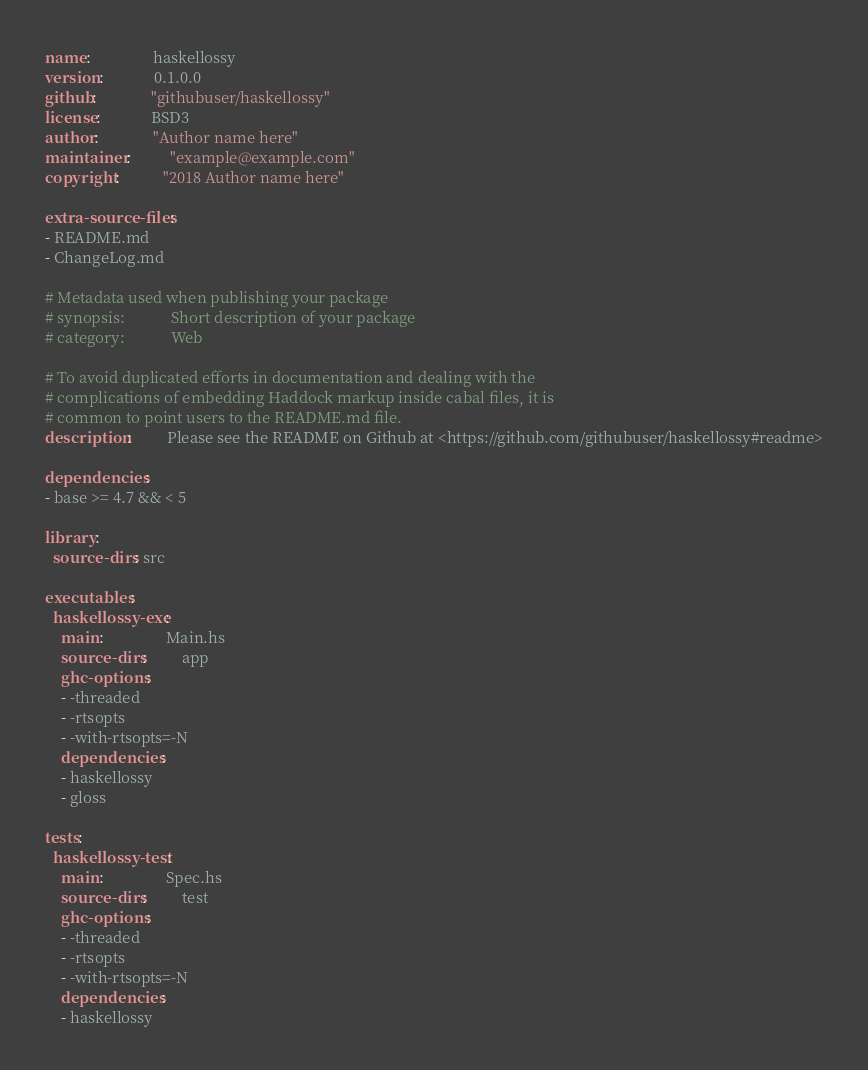<code> <loc_0><loc_0><loc_500><loc_500><_YAML_>name:                haskellossy
version:             0.1.0.0
github:              "githubuser/haskellossy"
license:             BSD3
author:              "Author name here"
maintainer:          "example@example.com"
copyright:           "2018 Author name here"

extra-source-files:
- README.md
- ChangeLog.md

# Metadata used when publishing your package
# synopsis:            Short description of your package
# category:            Web

# To avoid duplicated efforts in documentation and dealing with the
# complications of embedding Haddock markup inside cabal files, it is
# common to point users to the README.md file.
description:         Please see the README on Github at <https://github.com/githubuser/haskellossy#readme>

dependencies:
- base >= 4.7 && < 5

library:
  source-dirs: src

executables:
  haskellossy-exe:
    main:                Main.hs
    source-dirs:         app
    ghc-options:
    - -threaded
    - -rtsopts
    - -with-rtsopts=-N
    dependencies:
    - haskellossy
    - gloss

tests:
  haskellossy-test:
    main:                Spec.hs
    source-dirs:         test
    ghc-options:
    - -threaded
    - -rtsopts
    - -with-rtsopts=-N
    dependencies:
    - haskellossy
</code> 